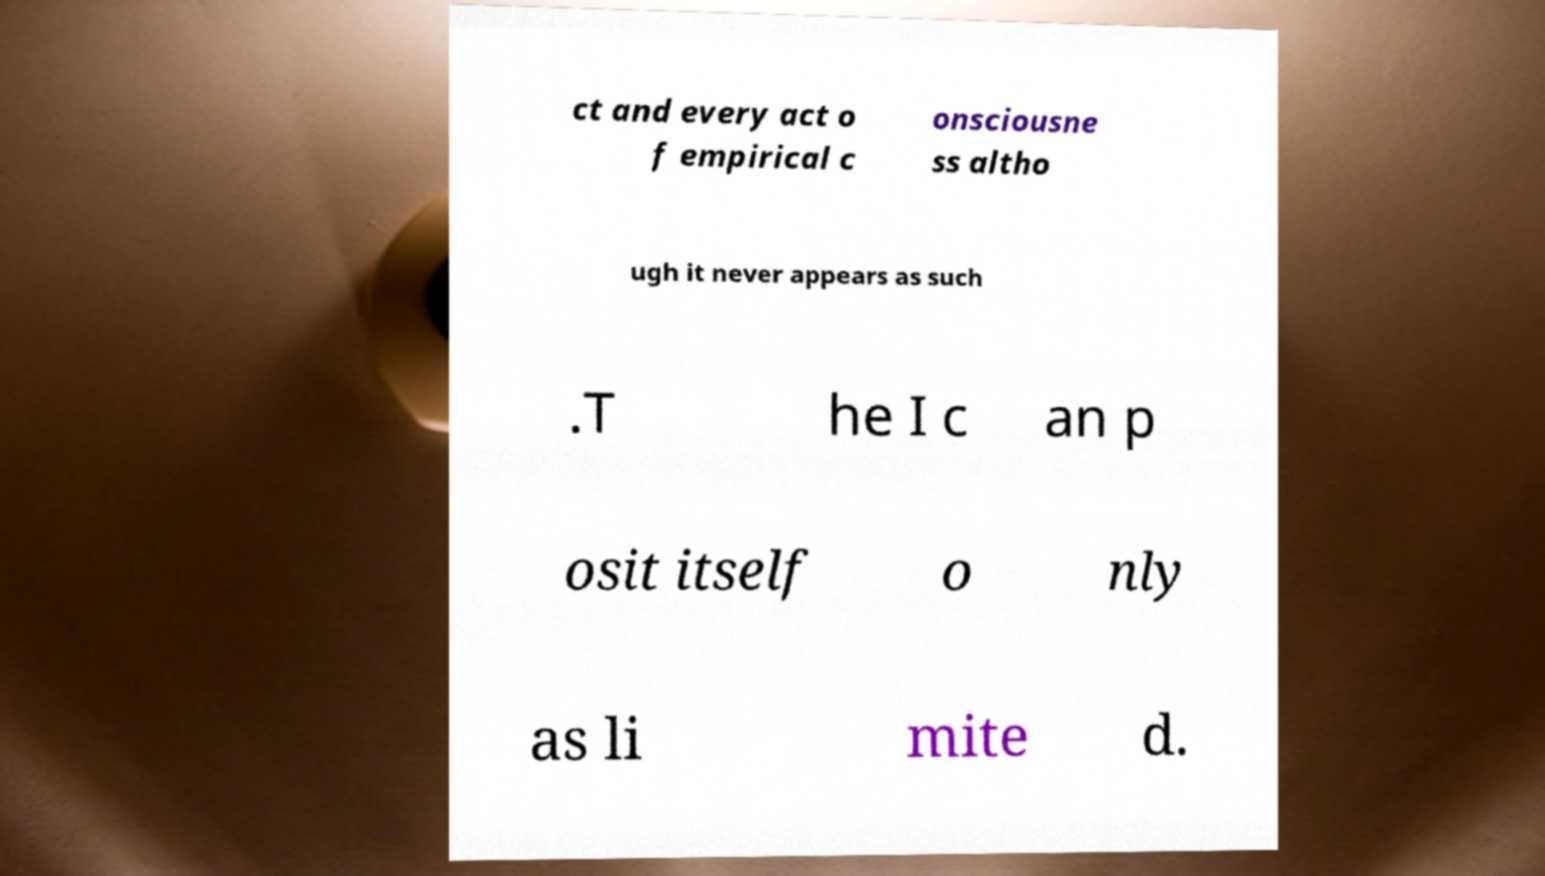Please identify and transcribe the text found in this image. ct and every act o f empirical c onsciousne ss altho ugh it never appears as such .T he I c an p osit itself o nly as li mite d. 